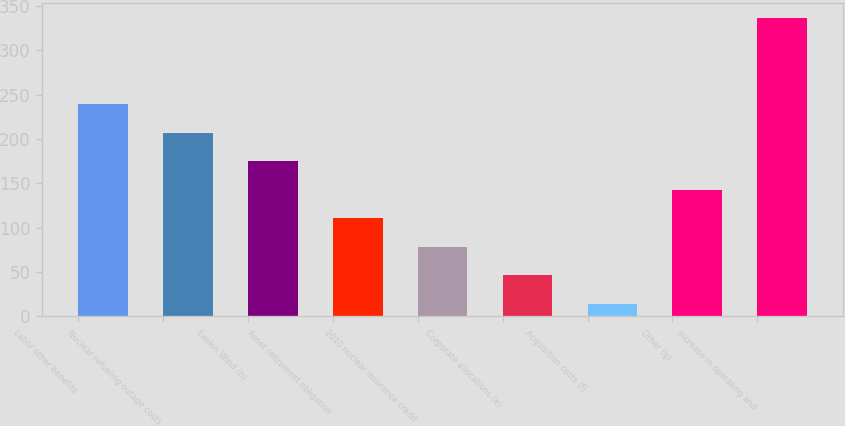Convert chart to OTSL. <chart><loc_0><loc_0><loc_500><loc_500><bar_chart><fcel>Labor other benefits<fcel>Nuclear refueling outage costs<fcel>Exelon Wind (b)<fcel>Asset retirement obligation<fcel>2010 nuclear insurance credit<fcel>Corporate allocations (e)<fcel>Acquisition costs (f)<fcel>Other (g)<fcel>Increase in operating and<nl><fcel>239.4<fcel>207.2<fcel>175<fcel>110.6<fcel>78.4<fcel>46.2<fcel>14<fcel>142.8<fcel>336<nl></chart> 